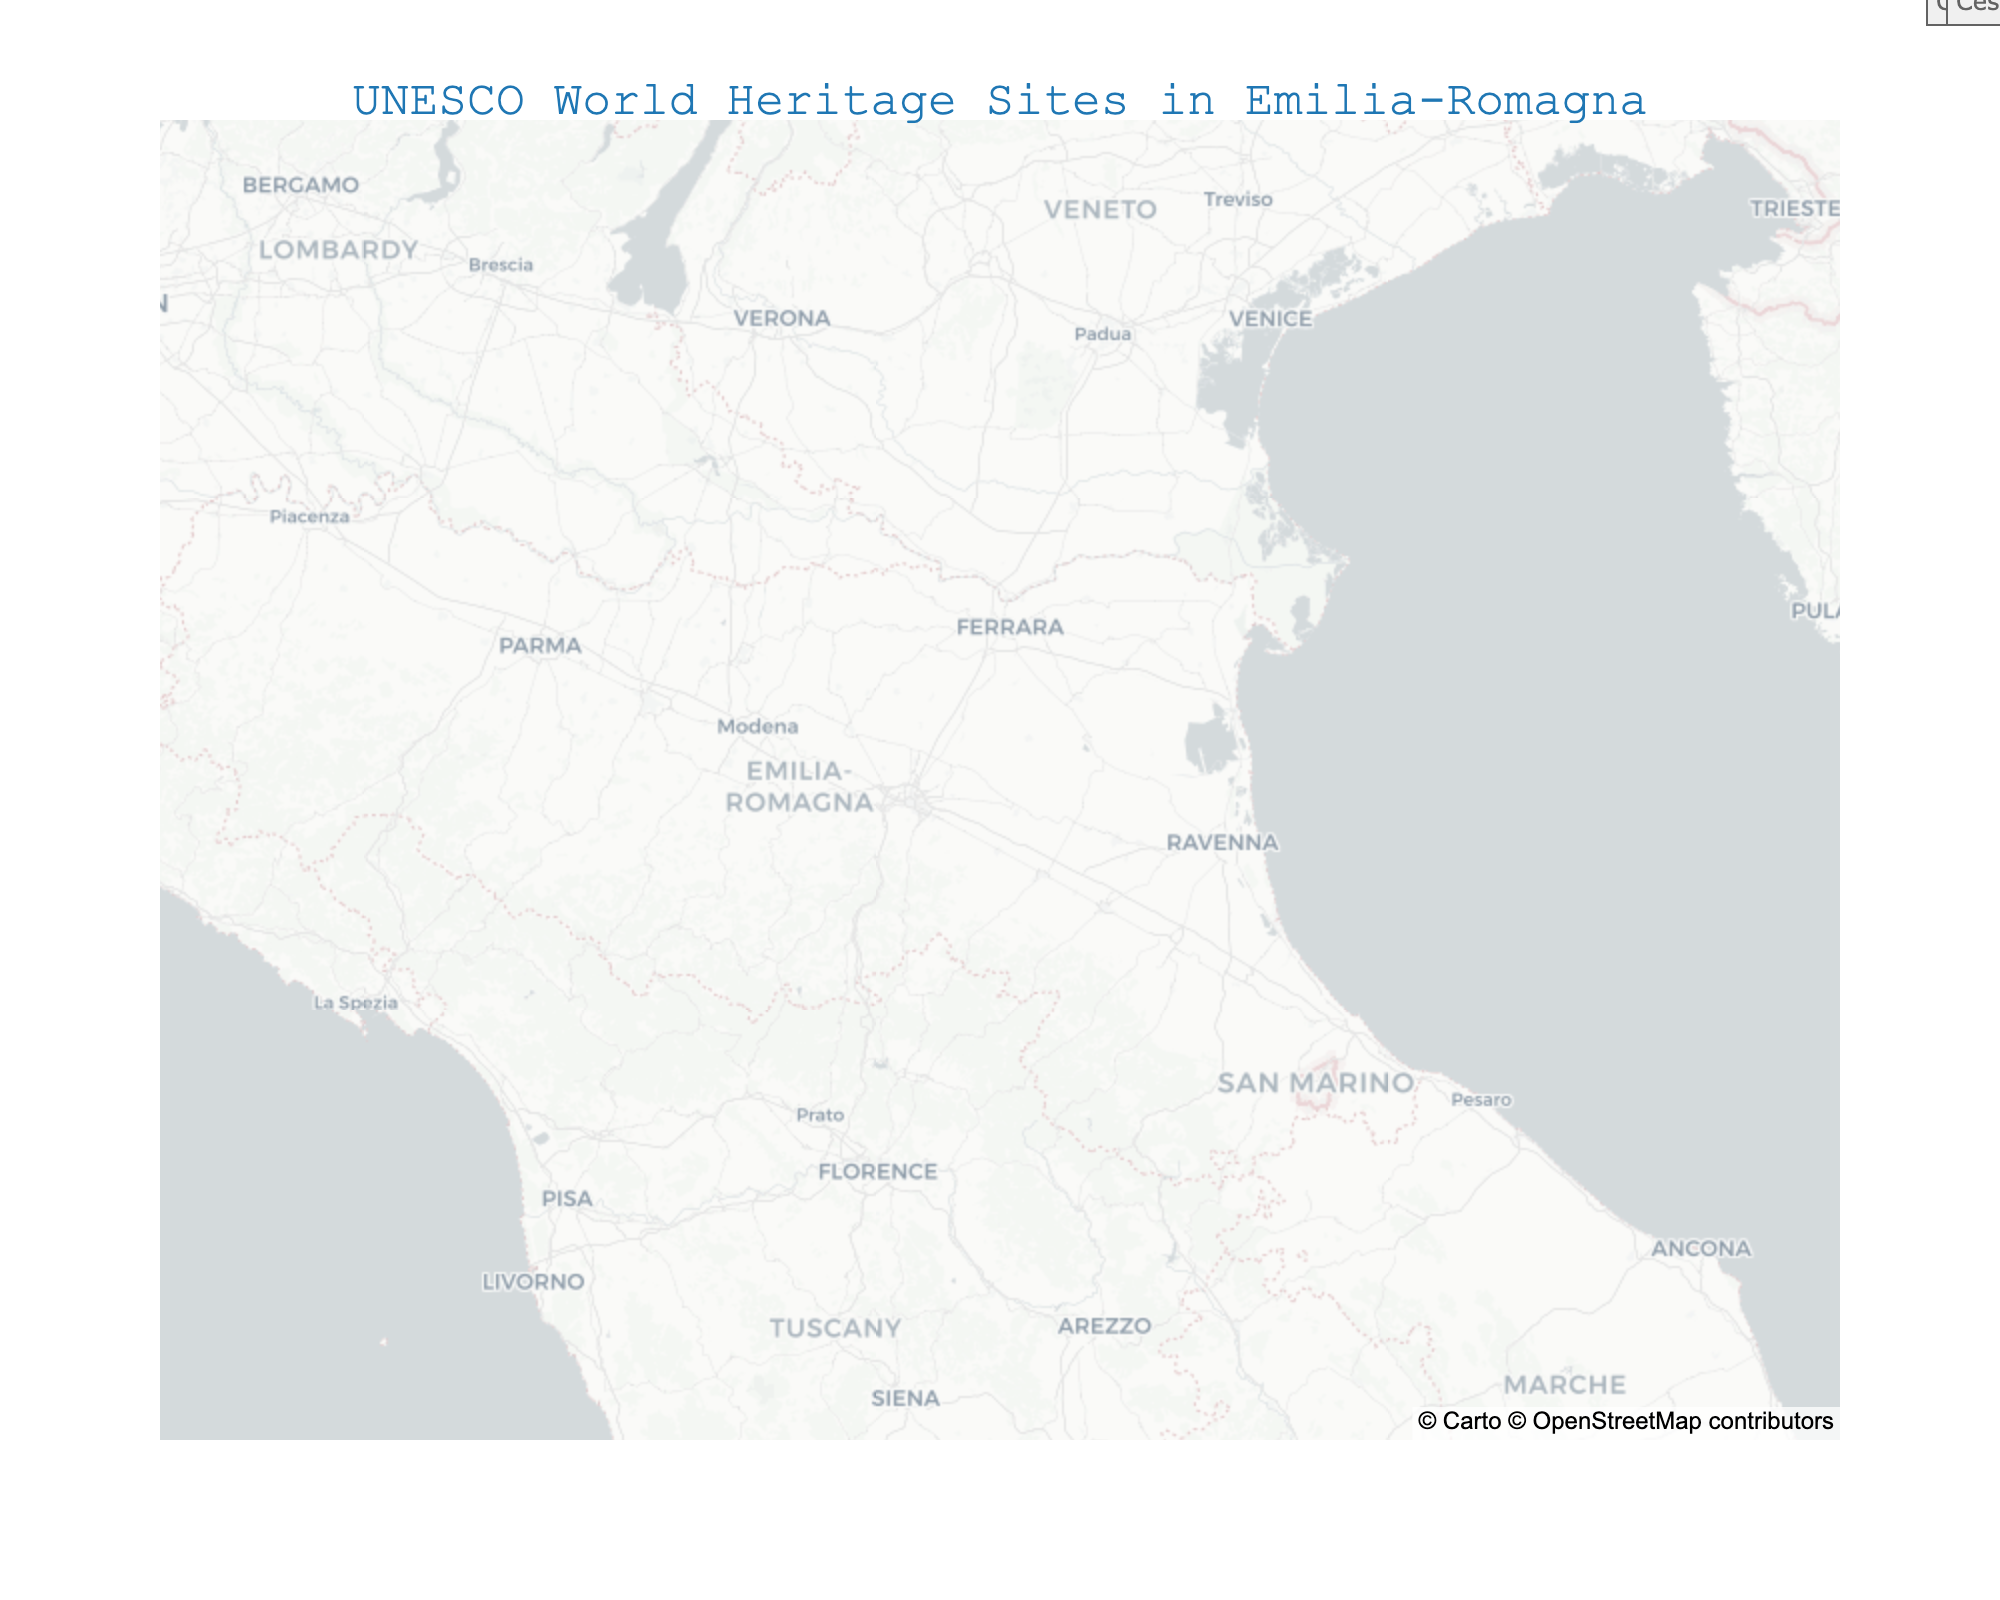what is the title of the figure? The title of the figure is displayed at the top center and often explains what the plot represents in a few words. Looking at the top of the map, we can see the title, "UNESCO World Heritage Sites in Emilia-Romagna."
Answer: UNESCO World Heritage Sites in Emilia-Romagna how many UNESCO World Heritage sites are marked on the map? You can count the number of star markers on the map that correspond to different sites in Emilia-Romagna. There are eight star markers in total.
Answer: 8 which site is the northernmost? By observing the latitude coordinates (y-axis) on the map, we can determine which site is situated at the highest latitude. According to the plot, Ferrara is the northernmost site.
Answer: Ferrara compare the inscription years of Modena and Comacchio, which one was inscribed first? By checking the hover data or labels, we can see the inscription years for Modena and Comacchio. Modena was inscribed in 1997, and Comacchio in 1999. Thus, Modena was inscribed first.
Answer: Modena what types of UNESCO sites does Emilia-Romagna have? Observing the hover data or the text labels next to each site, we see different types including City, Monuments, Porticoes, Ceramics, Nature, Gastronomy, and Library.
Answer: City, Monuments, Porticoes, Ceramics, Nature, Gastronomy, Library what is the mean latitude of all sites? To find the mean latitude, sum all the latitude values and divide by the number of sites: (44.8376 + 44.6471 + 44.4183 + 44.4949 + 44.2898 + 44.6946 + 44.8015 + 44.1396) / 8 = 44.540425.
Answer: 44.540425 which cities have been inscribed in 2021? By looking at the year inscribed in the hover data, we can identify the sites inscribed in 2021. These are Bologna, Faenza, and Cesena.
Answer: Bologna, Faenza, Cesena how does Ferrara's significance stand out in the visual compared to other sites? Ferrara is highlighted as one of the earliest inscribed UNESCO sites in the region and is geographically prominent as the northernmost site. This visual distinction emphasizes its historical and cultural significance within Emilia-Romagna.
Answer: Earliest inscription, northernmost site compare the number of inscribed sites before and after 2000. Which period had more sites inscribed? Count the sites based on their inscription years: Before 2000: Ferrara (1995), Modena (1997), Ravenna (1996), Comacchio (1999) = 4 sites. After 2000: Parma (2020), Bologna (2021), Faenza (2021), Cesena (2021) = 4 sites. Both periods had the same number of sites inscribed.
Answer: equal number of sites what site represents Nature in Emilia-Romagna? Looking at the plot's hover data or labels, the site assigned to Nature is Comacchio, inscribed in 1999.
Answer: Comacchio 